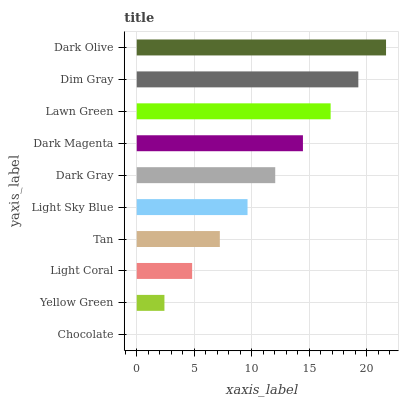Is Chocolate the minimum?
Answer yes or no. Yes. Is Dark Olive the maximum?
Answer yes or no. Yes. Is Yellow Green the minimum?
Answer yes or no. No. Is Yellow Green the maximum?
Answer yes or no. No. Is Yellow Green greater than Chocolate?
Answer yes or no. Yes. Is Chocolate less than Yellow Green?
Answer yes or no. Yes. Is Chocolate greater than Yellow Green?
Answer yes or no. No. Is Yellow Green less than Chocolate?
Answer yes or no. No. Is Dark Gray the high median?
Answer yes or no. Yes. Is Light Sky Blue the low median?
Answer yes or no. Yes. Is Light Coral the high median?
Answer yes or no. No. Is Dark Olive the low median?
Answer yes or no. No. 